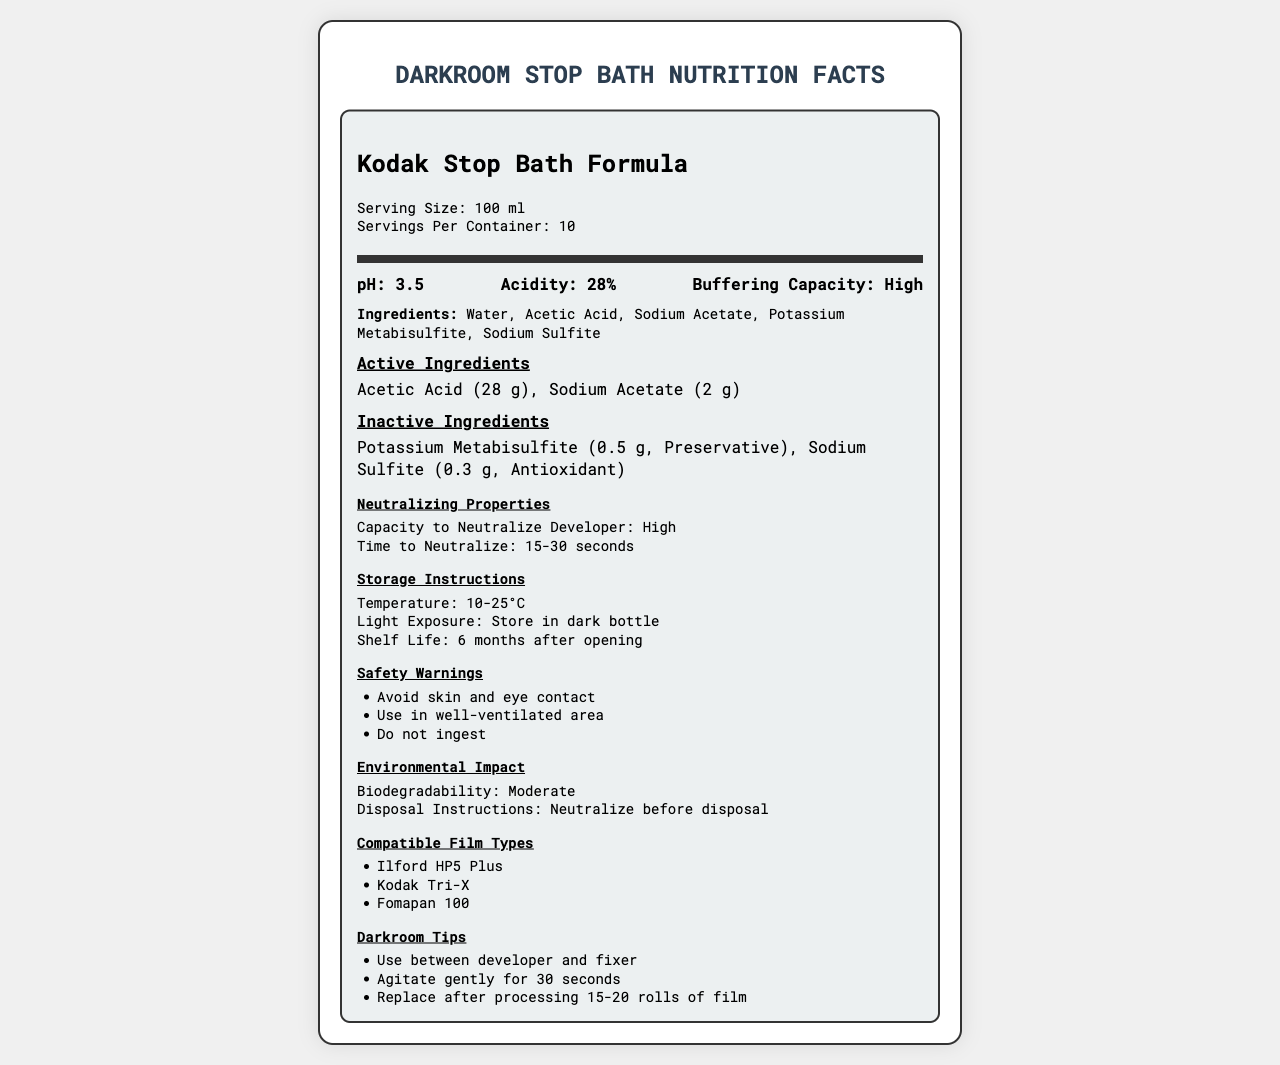what is the serving size? The serving size is explicitly mentioned in the second section of the document.
Answer: 100 ml what is the pH level of the Kodak Stop Bath Formula? The chemical properties section mentions the pH level as 3.5.
Answer: 3.5 how many servings are there per container? This information is provided in the serving info section under the product name.
Answer: 10 which ingredient acts as a preservative? The inactive ingredients section lists Potassium Metabisulfite with the function "Preservative."
Answer: Potassium Metabisulfite what is the total amount of Acetic Acid in the formula? The active ingredients section specifically states Acetic Acid has an amount of 28 g.
Answer: 28 g what should be the storage temperature for the Kodak Stop Bath Formula? A. 0-5°C B. 10-25°C C. 30-35°C According to the storage instructions, the temperature should be maintained between 10-25°C.
Answer: B which of the following film types is compatible with this stop bath formula? I. Kodak Portra II. Kodak Tri-X III. Ilford HP5 Plus A. I only B. II and III only C. I, II, and III Compatible Film Types section lists Kodak Tri-X and Ilford HP5 Plus, but not Kodak Portra.
Answer: B is the darkroom tip to agitate continuously for 30 seconds? The darkroom tip instructs to "agitate gently for 30 seconds," not continuously.
Answer: No describe the main ideas presented in the document. The document is structured to offer comprehensive information about the stop bath formula, from its chemical composition and safety measures to its application and compatibility with different film types.
Answer: The document provides details on Kodak Stop Bath Formula, including serving size, chemical properties, active and inactive ingredients, neutralizing properties, storage instructions, safety warnings, environmental impact, compatible film types, and some practical darkroom tips. how often should the stop bath be replaced after processing rolls of film? The darkroom tips section advises replacing the stop bath after processing 15-20 rolls of film.
Answer: After processing 15-20 rolls of film what is the shelf life of the Kodak Stop Bath Formula after opening? This information is mentioned in the storage instructions section.
Answer: 6 months is the environmental impact of the formula labeled as highly biodegradable? The environmental impact section states the biodegradability as "Moderate."
Answer: No what percentage of the formula's acidity is contributed by Acetic Acid? While the acidity percentage is given as 28%, there is no specific breakdown of how much each component contributes to this overall acidity in the document.
Answer: Cannot be determined 